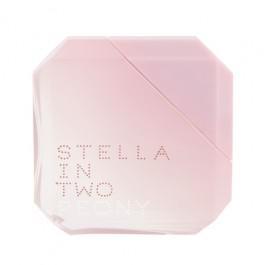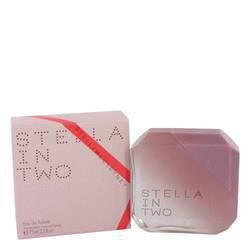The first image is the image on the left, the second image is the image on the right. For the images shown, is this caption "One image contains a bottle shaped like an inverted triangle with its triangular cap alongside it, and the other image includes a bevel-edged square pink object." true? Answer yes or no. No. The first image is the image on the left, the second image is the image on the right. Examine the images to the left and right. Is the description "A perfume bottle is standing on one corner with the lid off." accurate? Answer yes or no. No. 